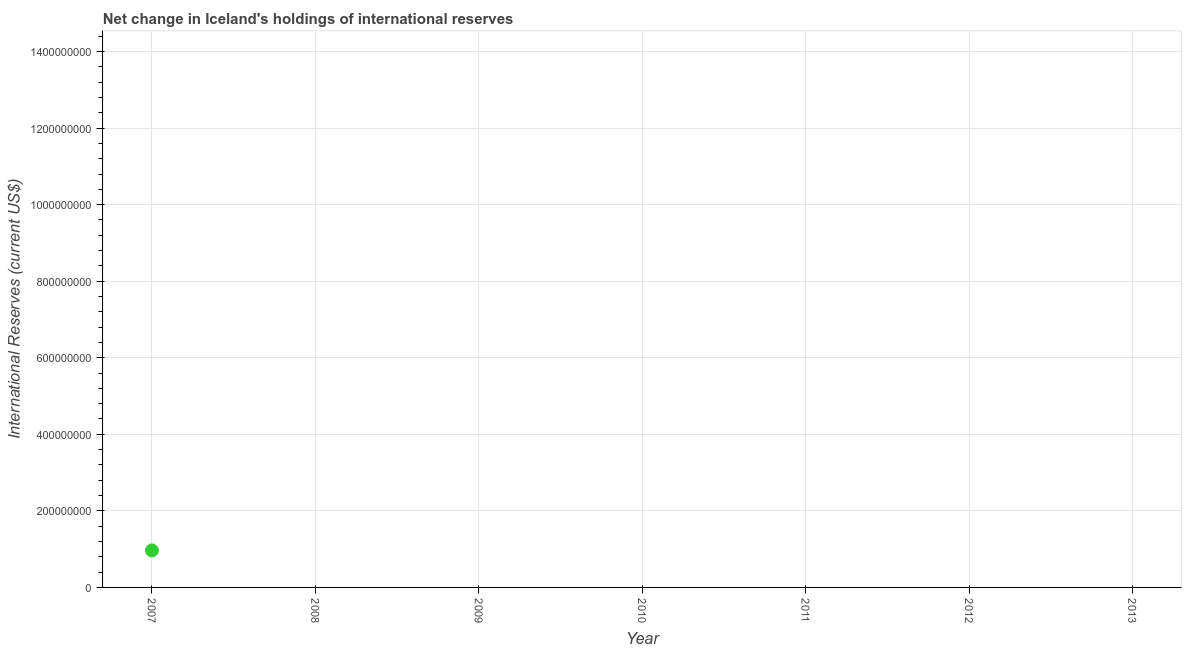Across all years, what is the maximum reserves and related items?
Offer a terse response. 9.67e+07. What is the sum of the reserves and related items?
Your answer should be compact. 9.67e+07. What is the average reserves and related items per year?
Make the answer very short. 1.38e+07. What is the difference between the highest and the lowest reserves and related items?
Your answer should be compact. 9.67e+07. In how many years, is the reserves and related items greater than the average reserves and related items taken over all years?
Give a very brief answer. 1. Does the graph contain grids?
Provide a succinct answer. Yes. What is the title of the graph?
Keep it short and to the point. Net change in Iceland's holdings of international reserves. What is the label or title of the Y-axis?
Your response must be concise. International Reserves (current US$). What is the International Reserves (current US$) in 2007?
Your response must be concise. 9.67e+07. What is the International Reserves (current US$) in 2008?
Provide a succinct answer. 0. What is the International Reserves (current US$) in 2011?
Provide a short and direct response. 0. What is the International Reserves (current US$) in 2013?
Give a very brief answer. 0. 